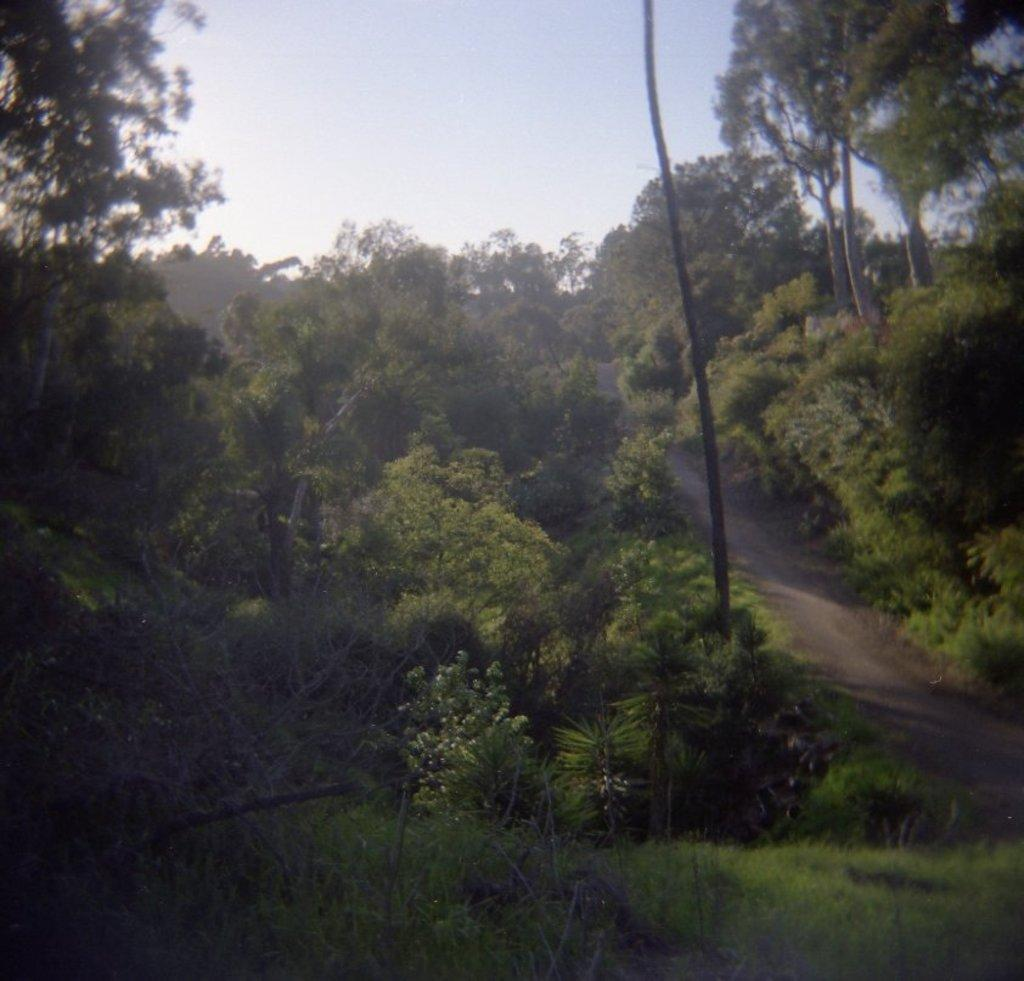What type of vegetation can be seen in the image? There is a group of trees and grass in the image. Can you describe any specific features of the trees? The bark of a tree is visible in the image. What type of surface is present for walking or traveling in the image? There is a pathway in the image. What can be seen in the background of the image? The sky is visible in the background of the image. What type of wren can be seen perched on the tree in the image? There is no wren present in the image; only trees, grass, a pathway, and the sky are visible. Is there a writer sitting on the grass in the image? There is no writer present in the image; only trees, grass, a pathway, and the sky are visible. 